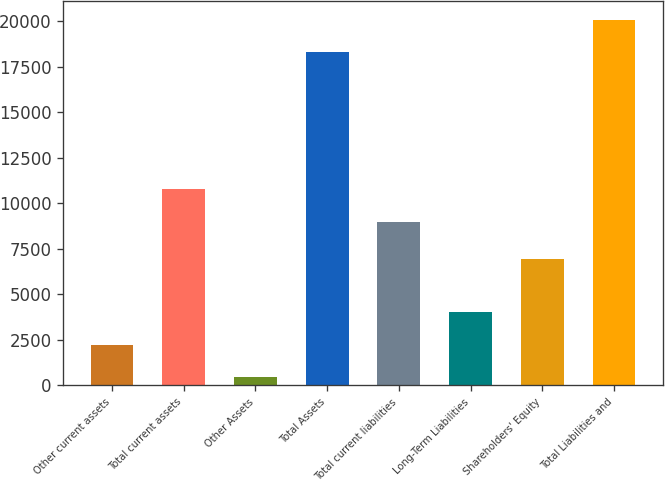<chart> <loc_0><loc_0><loc_500><loc_500><bar_chart><fcel>Other current assets<fcel>Total current assets<fcel>Other Assets<fcel>Total Assets<fcel>Total current liabilities<fcel>Long-Term Liabilities<fcel>Shareholders' Equity<fcel>Total Liabilities and<nl><fcel>2237<fcel>10763<fcel>452<fcel>18302<fcel>8978<fcel>4022<fcel>6964<fcel>20087<nl></chart> 